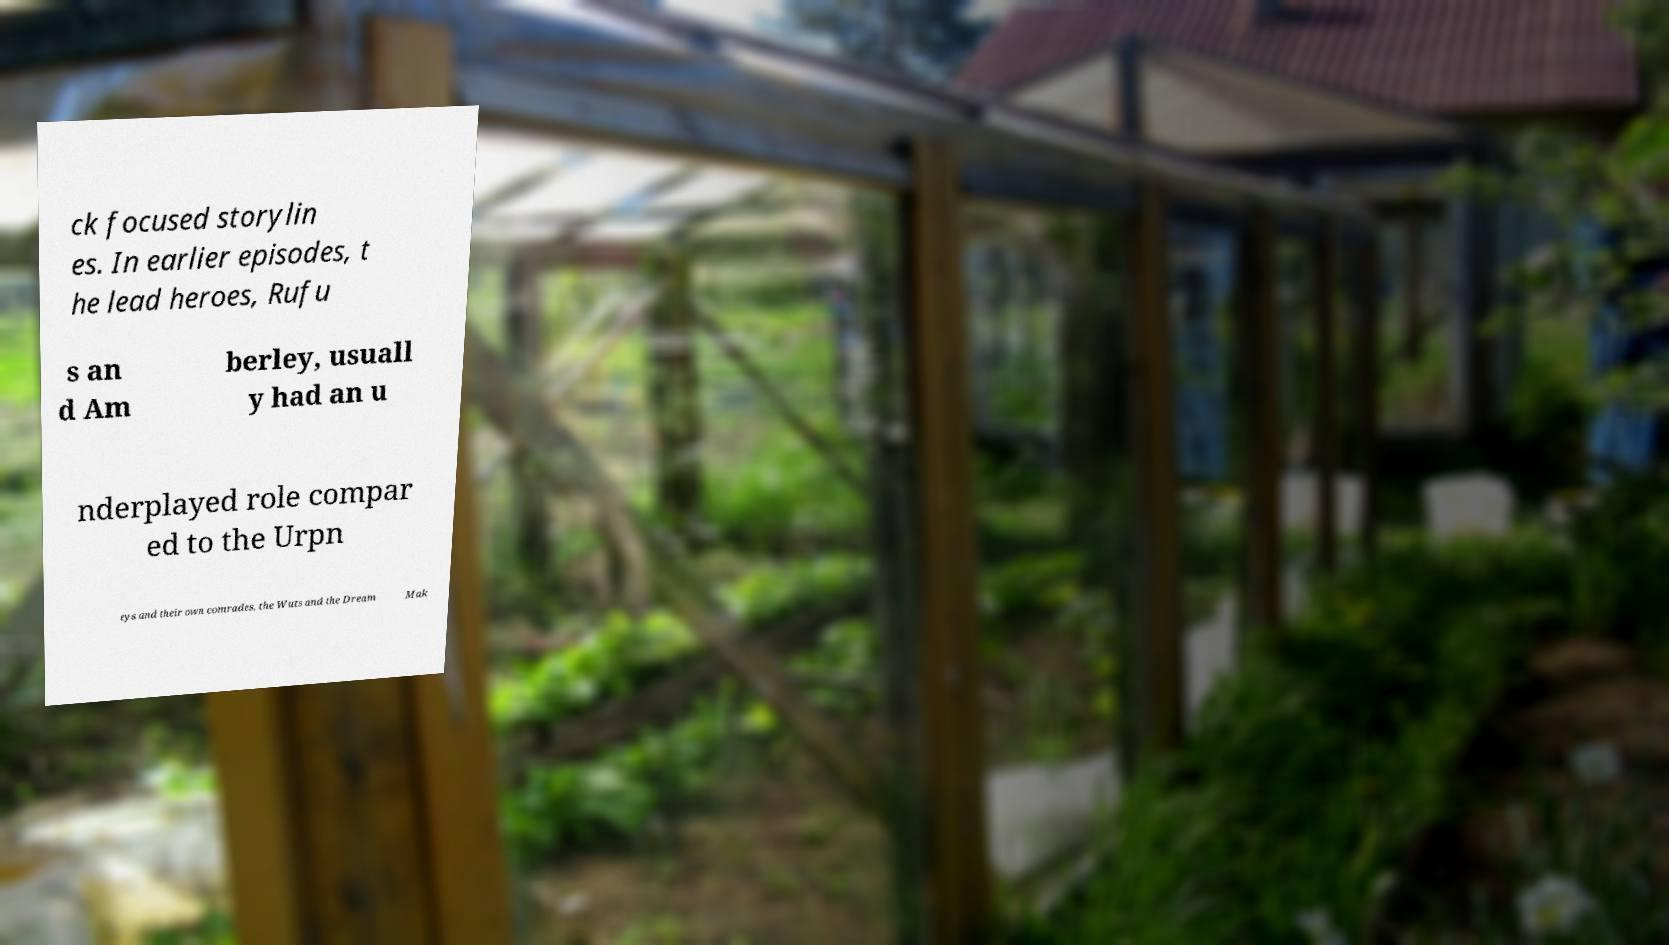Can you read and provide the text displayed in the image?This photo seems to have some interesting text. Can you extract and type it out for me? ck focused storylin es. In earlier episodes, t he lead heroes, Rufu s an d Am berley, usuall y had an u nderplayed role compar ed to the Urpn eys and their own comrades, the Wuts and the Dream Mak 